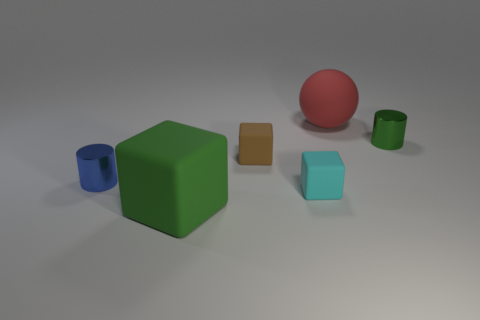Add 1 large red matte objects. How many objects exist? 7 Subtract all cylinders. How many objects are left? 4 Subtract all tiny purple metallic things. Subtract all tiny cyan objects. How many objects are left? 5 Add 5 cyan rubber cubes. How many cyan rubber cubes are left? 6 Add 4 green matte things. How many green matte things exist? 5 Subtract 0 purple blocks. How many objects are left? 6 